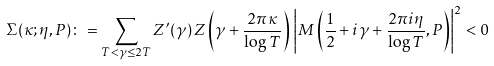Convert formula to latex. <formula><loc_0><loc_0><loc_500><loc_500>\Sigma ( \kappa ; \eta , P ) \colon = \sum _ { T < \gamma \leq 2 T } Z ^ { \prime } ( \gamma ) \, Z \left ( \gamma + \frac { 2 \pi \kappa } { \log T } \right ) \, \left | M \left ( \frac { 1 } { 2 } + i \gamma + \frac { 2 \pi i \eta } { \log T } , P \right ) \right | ^ { 2 } < 0</formula> 